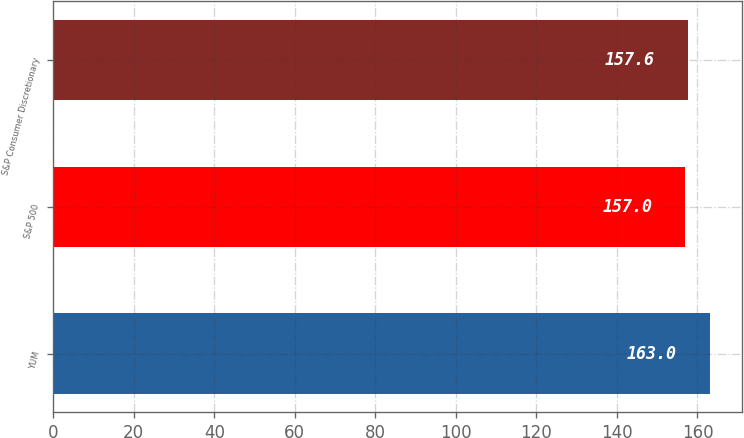<chart> <loc_0><loc_0><loc_500><loc_500><bar_chart><fcel>YUM<fcel>S&P 500<fcel>S&P Consumer Discretionary<nl><fcel>163<fcel>157<fcel>157.6<nl></chart> 